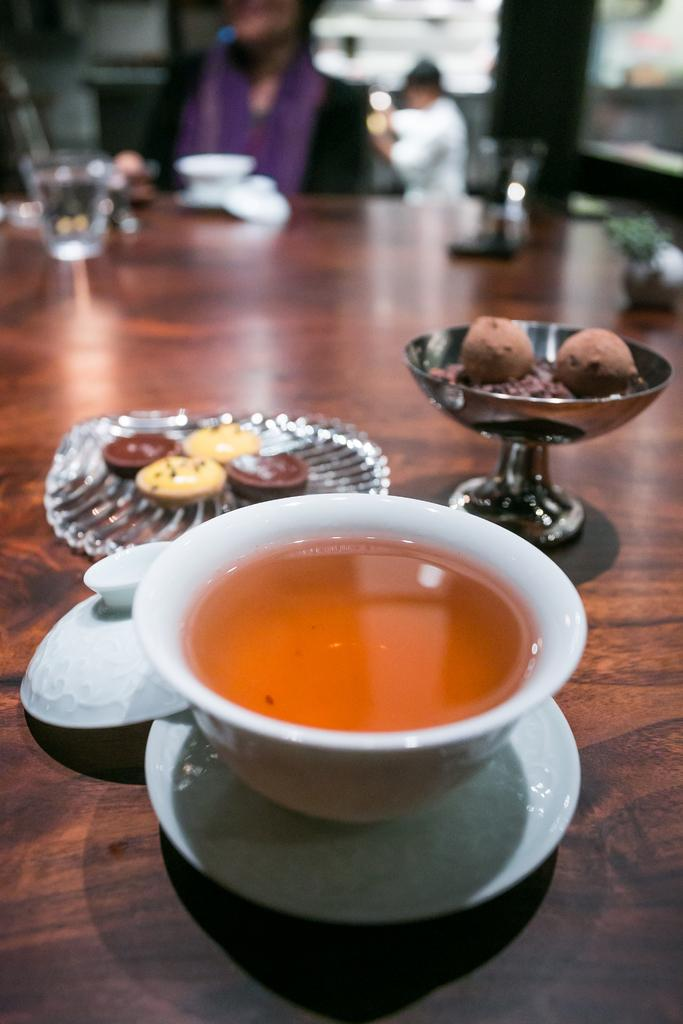What is in the bowl that is visible in the image? There is food in a bowl in the image. What other tableware can be seen in the image? There is a plate, a cup, and a glass visible in the image. What is the status of the bowl's lid in the image? The lid of a bowl is placed aside in the image. Are there any people visible in the image? Yes, there are two people visible on the backside of the image. What type of form is the breakfast taking in the image? There is no reference to breakfast in the image, and the food in the bowl is not specified as breakfast. 